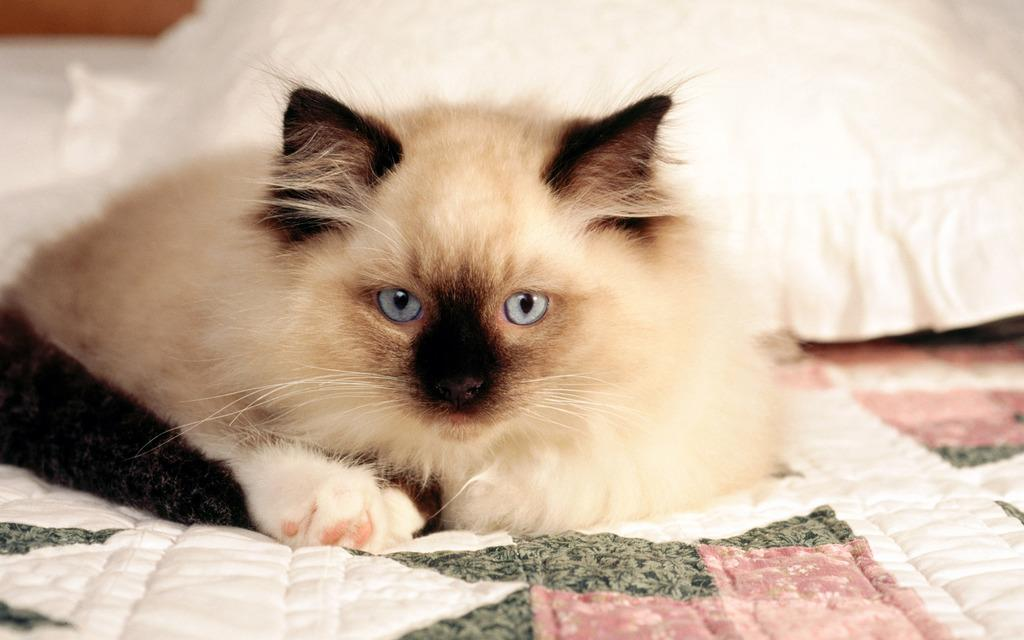What animal is present in the image? There is a cat in the image. Where is the cat located? The cat is sitting on a bed. What is behind the cat? There is a pillow behind the cat. What type of trousers is the cat wearing in the image? Cats do not wear trousers, so there is no information about trousers in the image. 